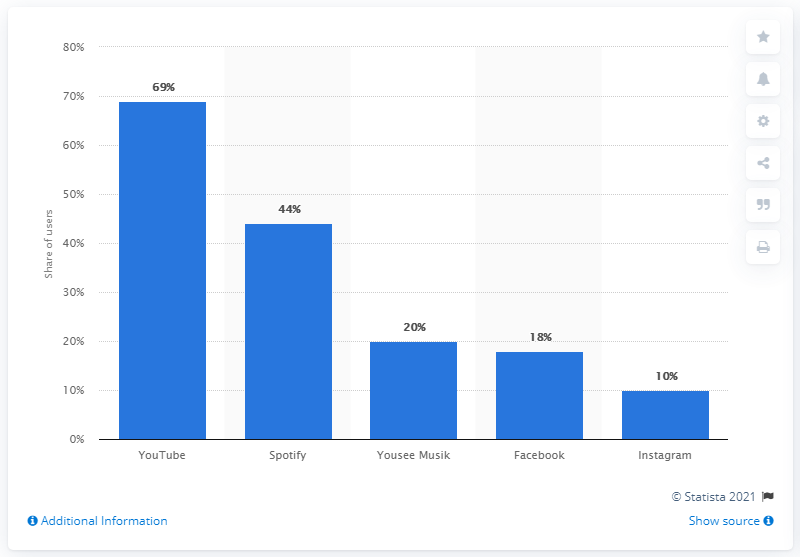Which digital music service is the second most used in Denmark? Spotify is the second most used service for digital music in Denmark, with a 44% share of users as per the displayed bar chart. 